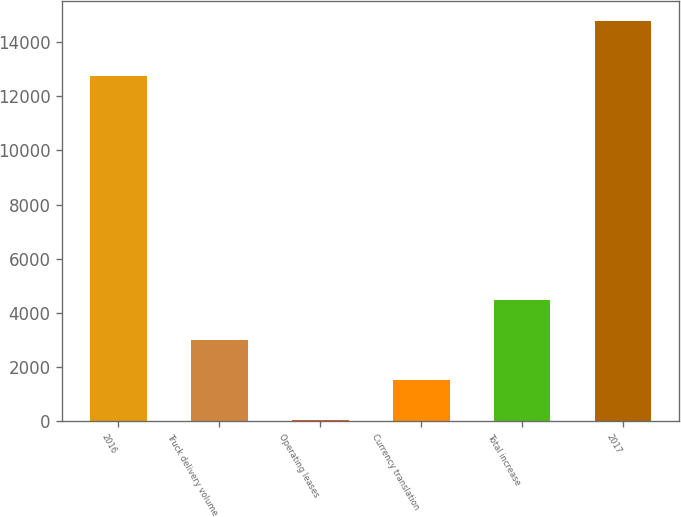<chart> <loc_0><loc_0><loc_500><loc_500><bar_chart><fcel>2016<fcel>Truck delivery volume<fcel>Operating leases<fcel>Currency translation<fcel>Total increase<fcel>2017<nl><fcel>12767.3<fcel>2977.44<fcel>28.1<fcel>1502.77<fcel>4452.11<fcel>14774.8<nl></chart> 